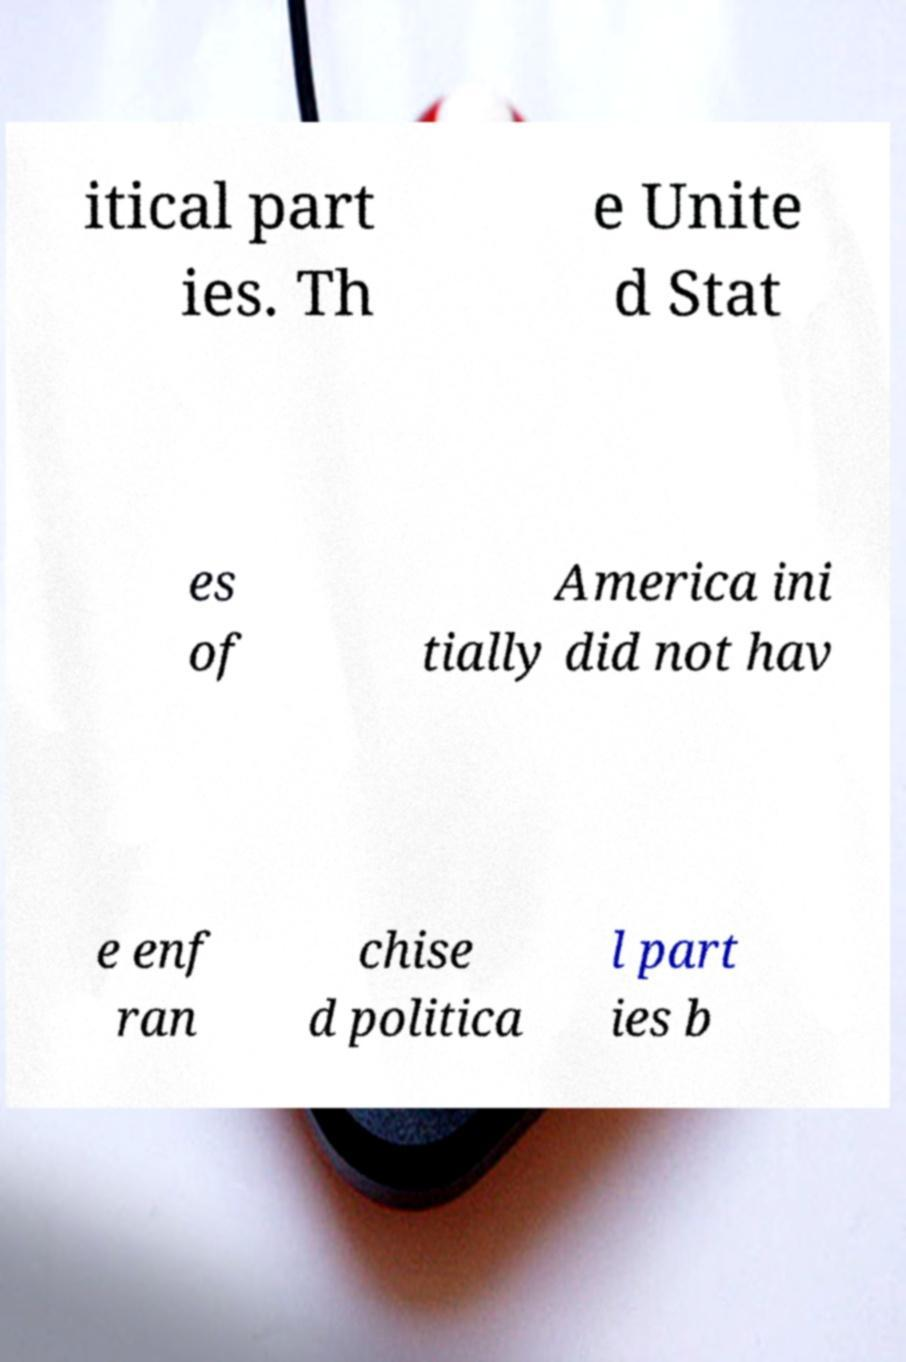What messages or text are displayed in this image? I need them in a readable, typed format. itical part ies. Th e Unite d Stat es of America ini tially did not hav e enf ran chise d politica l part ies b 